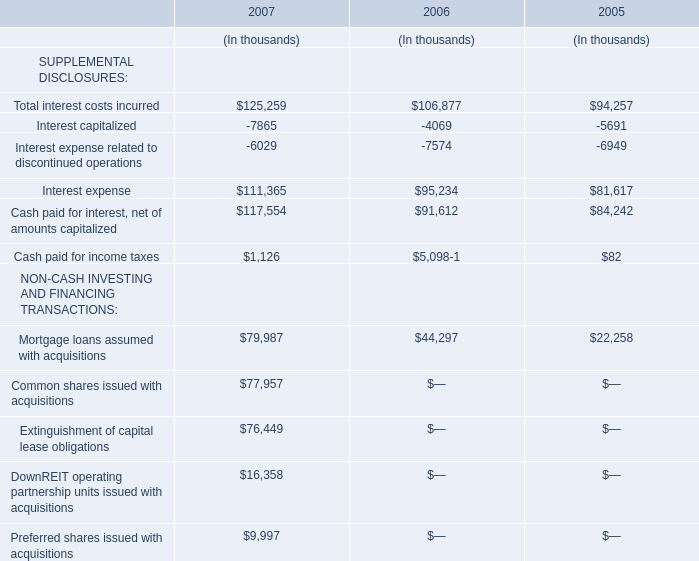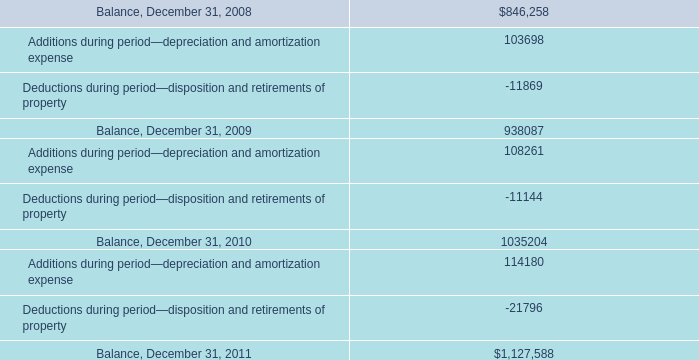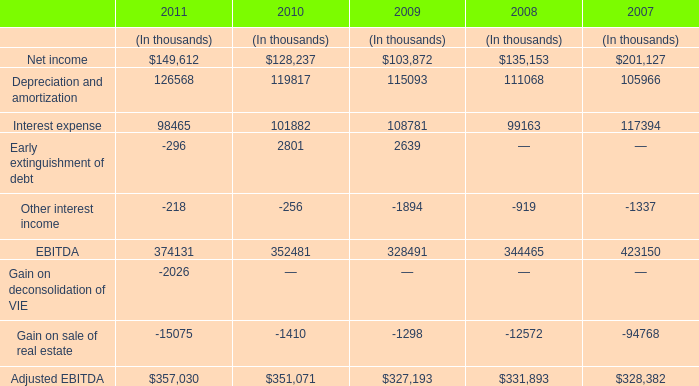What is the ratio of Interest expense in Table 2 to the Mortgage loans assumed with acquisitions in Table 0 in 2007? 
Computations: (117394 / 79987)
Answer: 1.46766. 